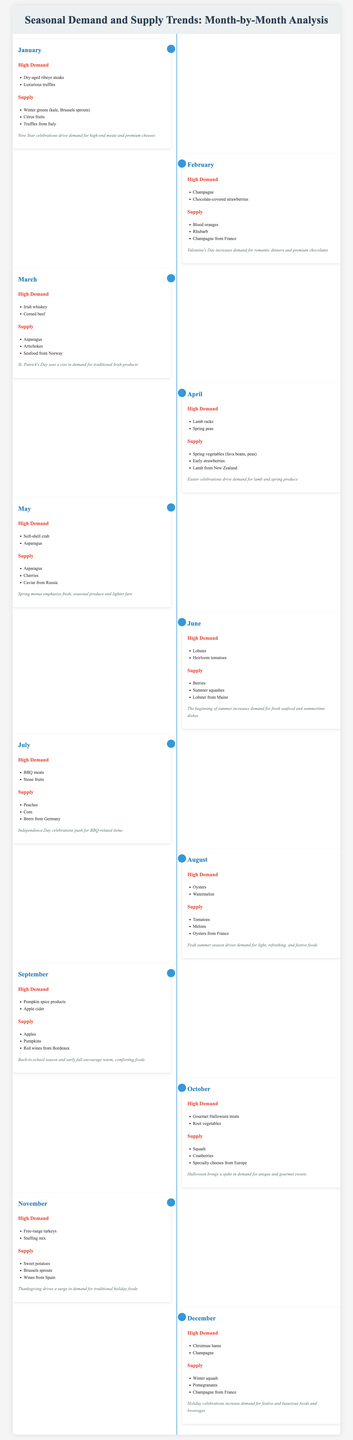What is the high-demand item for January? The high-demand items listed for January are dry-aged ribeye steaks and luxurious truffles.
Answer: Dry-aged ribeye steaks What type of champagne is mentioned in February? The document states that champagne from France is in high demand during February.
Answer: Champagne from France Which two items are in high demand in April? Based on the timeline, the high-demand items in April are lamb racks and spring peas.
Answer: Lamb racks, spring peas What supply item is specific to June? The supply item specifically mentioned for June is lobster from Maine.
Answer: Lobster from Maine What seasonal food trends are highlighted in September? The timeline indicates that pumpkin spice products and apple cider are in high demand during September.
Answer: Pumpkin spice products, apple cider Why does demand increase for BBQ-related items in July? Independence Day celebrations push for BBQ-related items, resulting in increased demand.
Answer: Independence Day celebrations What are the high-demand products for October? The high-demand products for October are gourmet Halloween treats and root vegetables.
Answer: Gourmet Halloween treats, root vegetables Which type of meat sees a surge in November? Free-range turkeys are highlighted as seeing high demand during November.
Answer: Free-range turkeys What type of squash is available in December? The supply items for December include winter squash.
Answer: Winter squash 